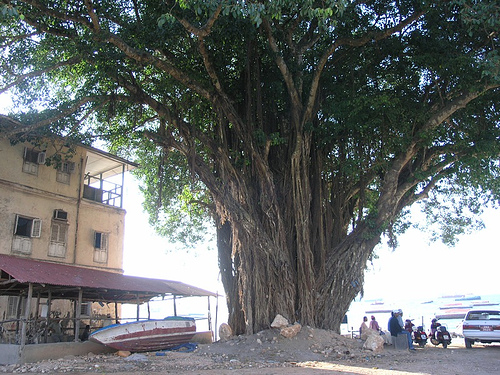<image>
Can you confirm if the tree is next to the house? Yes. The tree is positioned adjacent to the house, located nearby in the same general area. Is there a boat under the window? No. The boat is not positioned under the window. The vertical relationship between these objects is different. 